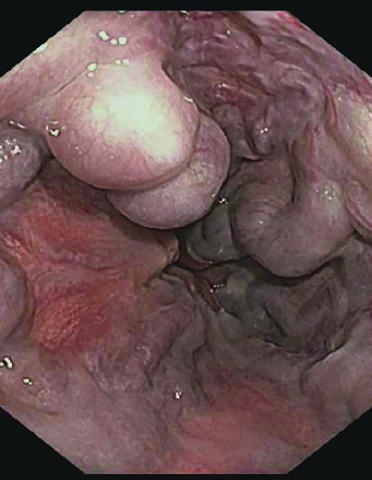what is endoscopy more commonly used to?
Answer the question using a single word or phrase. Identify varices 